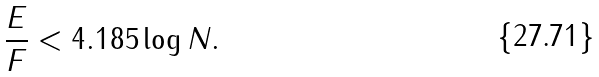<formula> <loc_0><loc_0><loc_500><loc_500>\frac { E } { F } < 4 . 1 8 5 \log N .</formula> 